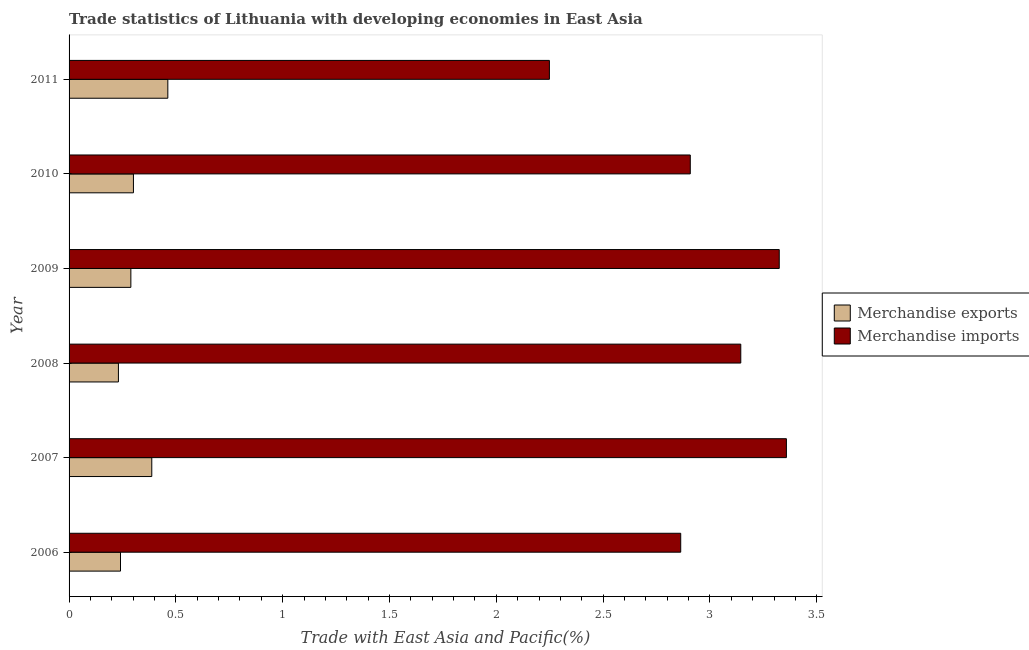Are the number of bars per tick equal to the number of legend labels?
Offer a very short reply. Yes. Are the number of bars on each tick of the Y-axis equal?
Make the answer very short. Yes. In how many cases, is the number of bars for a given year not equal to the number of legend labels?
Provide a short and direct response. 0. What is the merchandise imports in 2006?
Ensure brevity in your answer.  2.86. Across all years, what is the maximum merchandise exports?
Your response must be concise. 0.46. Across all years, what is the minimum merchandise exports?
Provide a succinct answer. 0.23. In which year was the merchandise exports maximum?
Ensure brevity in your answer.  2011. In which year was the merchandise imports minimum?
Provide a short and direct response. 2011. What is the total merchandise imports in the graph?
Your answer should be very brief. 17.85. What is the difference between the merchandise imports in 2007 and that in 2009?
Your answer should be very brief. 0.03. What is the difference between the merchandise exports in 2009 and the merchandise imports in 2007?
Make the answer very short. -3.07. What is the average merchandise exports per year?
Make the answer very short. 0.32. In the year 2008, what is the difference between the merchandise exports and merchandise imports?
Provide a short and direct response. -2.91. In how many years, is the merchandise imports greater than 1.4 %?
Your response must be concise. 6. What is the ratio of the merchandise exports in 2007 to that in 2010?
Keep it short and to the point. 1.28. What is the difference between the highest and the second highest merchandise exports?
Keep it short and to the point. 0.07. What is the difference between the highest and the lowest merchandise exports?
Keep it short and to the point. 0.23. In how many years, is the merchandise imports greater than the average merchandise imports taken over all years?
Keep it short and to the point. 3. What does the 2nd bar from the top in 2008 represents?
Make the answer very short. Merchandise exports. How many bars are there?
Your answer should be very brief. 12. Are all the bars in the graph horizontal?
Provide a succinct answer. Yes. How many years are there in the graph?
Offer a terse response. 6. Does the graph contain any zero values?
Offer a terse response. No. How many legend labels are there?
Your answer should be very brief. 2. What is the title of the graph?
Your response must be concise. Trade statistics of Lithuania with developing economies in East Asia. Does "IMF nonconcessional" appear as one of the legend labels in the graph?
Offer a very short reply. No. What is the label or title of the X-axis?
Provide a succinct answer. Trade with East Asia and Pacific(%). What is the label or title of the Y-axis?
Ensure brevity in your answer.  Year. What is the Trade with East Asia and Pacific(%) in Merchandise exports in 2006?
Your answer should be very brief. 0.24. What is the Trade with East Asia and Pacific(%) in Merchandise imports in 2006?
Your answer should be compact. 2.86. What is the Trade with East Asia and Pacific(%) in Merchandise exports in 2007?
Your response must be concise. 0.39. What is the Trade with East Asia and Pacific(%) of Merchandise imports in 2007?
Your answer should be very brief. 3.36. What is the Trade with East Asia and Pacific(%) in Merchandise exports in 2008?
Your answer should be compact. 0.23. What is the Trade with East Asia and Pacific(%) of Merchandise imports in 2008?
Your answer should be compact. 3.14. What is the Trade with East Asia and Pacific(%) in Merchandise exports in 2009?
Provide a succinct answer. 0.29. What is the Trade with East Asia and Pacific(%) of Merchandise imports in 2009?
Your answer should be compact. 3.32. What is the Trade with East Asia and Pacific(%) of Merchandise exports in 2010?
Make the answer very short. 0.3. What is the Trade with East Asia and Pacific(%) in Merchandise imports in 2010?
Offer a very short reply. 2.91. What is the Trade with East Asia and Pacific(%) in Merchandise exports in 2011?
Make the answer very short. 0.46. What is the Trade with East Asia and Pacific(%) in Merchandise imports in 2011?
Make the answer very short. 2.25. Across all years, what is the maximum Trade with East Asia and Pacific(%) in Merchandise exports?
Ensure brevity in your answer.  0.46. Across all years, what is the maximum Trade with East Asia and Pacific(%) of Merchandise imports?
Provide a short and direct response. 3.36. Across all years, what is the minimum Trade with East Asia and Pacific(%) of Merchandise exports?
Offer a very short reply. 0.23. Across all years, what is the minimum Trade with East Asia and Pacific(%) in Merchandise imports?
Offer a terse response. 2.25. What is the total Trade with East Asia and Pacific(%) of Merchandise exports in the graph?
Your answer should be very brief. 1.91. What is the total Trade with East Asia and Pacific(%) in Merchandise imports in the graph?
Your response must be concise. 17.85. What is the difference between the Trade with East Asia and Pacific(%) of Merchandise exports in 2006 and that in 2007?
Your response must be concise. -0.15. What is the difference between the Trade with East Asia and Pacific(%) of Merchandise imports in 2006 and that in 2007?
Offer a terse response. -0.49. What is the difference between the Trade with East Asia and Pacific(%) of Merchandise exports in 2006 and that in 2008?
Offer a terse response. 0.01. What is the difference between the Trade with East Asia and Pacific(%) of Merchandise imports in 2006 and that in 2008?
Your response must be concise. -0.28. What is the difference between the Trade with East Asia and Pacific(%) in Merchandise exports in 2006 and that in 2009?
Your answer should be very brief. -0.05. What is the difference between the Trade with East Asia and Pacific(%) in Merchandise imports in 2006 and that in 2009?
Provide a short and direct response. -0.46. What is the difference between the Trade with East Asia and Pacific(%) of Merchandise exports in 2006 and that in 2010?
Your response must be concise. -0.06. What is the difference between the Trade with East Asia and Pacific(%) in Merchandise imports in 2006 and that in 2010?
Make the answer very short. -0.04. What is the difference between the Trade with East Asia and Pacific(%) in Merchandise exports in 2006 and that in 2011?
Offer a very short reply. -0.22. What is the difference between the Trade with East Asia and Pacific(%) in Merchandise imports in 2006 and that in 2011?
Your answer should be very brief. 0.61. What is the difference between the Trade with East Asia and Pacific(%) in Merchandise exports in 2007 and that in 2008?
Keep it short and to the point. 0.16. What is the difference between the Trade with East Asia and Pacific(%) of Merchandise imports in 2007 and that in 2008?
Your response must be concise. 0.21. What is the difference between the Trade with East Asia and Pacific(%) in Merchandise exports in 2007 and that in 2009?
Ensure brevity in your answer.  0.1. What is the difference between the Trade with East Asia and Pacific(%) of Merchandise imports in 2007 and that in 2009?
Keep it short and to the point. 0.03. What is the difference between the Trade with East Asia and Pacific(%) in Merchandise exports in 2007 and that in 2010?
Make the answer very short. 0.09. What is the difference between the Trade with East Asia and Pacific(%) of Merchandise imports in 2007 and that in 2010?
Offer a very short reply. 0.45. What is the difference between the Trade with East Asia and Pacific(%) of Merchandise exports in 2007 and that in 2011?
Give a very brief answer. -0.08. What is the difference between the Trade with East Asia and Pacific(%) in Merchandise imports in 2007 and that in 2011?
Your answer should be very brief. 1.11. What is the difference between the Trade with East Asia and Pacific(%) in Merchandise exports in 2008 and that in 2009?
Make the answer very short. -0.06. What is the difference between the Trade with East Asia and Pacific(%) in Merchandise imports in 2008 and that in 2009?
Offer a terse response. -0.18. What is the difference between the Trade with East Asia and Pacific(%) in Merchandise exports in 2008 and that in 2010?
Your response must be concise. -0.07. What is the difference between the Trade with East Asia and Pacific(%) in Merchandise imports in 2008 and that in 2010?
Offer a terse response. 0.24. What is the difference between the Trade with East Asia and Pacific(%) in Merchandise exports in 2008 and that in 2011?
Keep it short and to the point. -0.23. What is the difference between the Trade with East Asia and Pacific(%) of Merchandise imports in 2008 and that in 2011?
Make the answer very short. 0.9. What is the difference between the Trade with East Asia and Pacific(%) in Merchandise exports in 2009 and that in 2010?
Offer a terse response. -0.01. What is the difference between the Trade with East Asia and Pacific(%) in Merchandise imports in 2009 and that in 2010?
Your response must be concise. 0.42. What is the difference between the Trade with East Asia and Pacific(%) in Merchandise exports in 2009 and that in 2011?
Keep it short and to the point. -0.17. What is the difference between the Trade with East Asia and Pacific(%) of Merchandise imports in 2009 and that in 2011?
Your answer should be compact. 1.08. What is the difference between the Trade with East Asia and Pacific(%) in Merchandise exports in 2010 and that in 2011?
Make the answer very short. -0.16. What is the difference between the Trade with East Asia and Pacific(%) in Merchandise imports in 2010 and that in 2011?
Your answer should be very brief. 0.66. What is the difference between the Trade with East Asia and Pacific(%) of Merchandise exports in 2006 and the Trade with East Asia and Pacific(%) of Merchandise imports in 2007?
Give a very brief answer. -3.12. What is the difference between the Trade with East Asia and Pacific(%) in Merchandise exports in 2006 and the Trade with East Asia and Pacific(%) in Merchandise imports in 2008?
Make the answer very short. -2.9. What is the difference between the Trade with East Asia and Pacific(%) in Merchandise exports in 2006 and the Trade with East Asia and Pacific(%) in Merchandise imports in 2009?
Give a very brief answer. -3.08. What is the difference between the Trade with East Asia and Pacific(%) of Merchandise exports in 2006 and the Trade with East Asia and Pacific(%) of Merchandise imports in 2010?
Your answer should be very brief. -2.67. What is the difference between the Trade with East Asia and Pacific(%) in Merchandise exports in 2006 and the Trade with East Asia and Pacific(%) in Merchandise imports in 2011?
Your response must be concise. -2.01. What is the difference between the Trade with East Asia and Pacific(%) of Merchandise exports in 2007 and the Trade with East Asia and Pacific(%) of Merchandise imports in 2008?
Keep it short and to the point. -2.76. What is the difference between the Trade with East Asia and Pacific(%) of Merchandise exports in 2007 and the Trade with East Asia and Pacific(%) of Merchandise imports in 2009?
Offer a terse response. -2.94. What is the difference between the Trade with East Asia and Pacific(%) in Merchandise exports in 2007 and the Trade with East Asia and Pacific(%) in Merchandise imports in 2010?
Your answer should be very brief. -2.52. What is the difference between the Trade with East Asia and Pacific(%) of Merchandise exports in 2007 and the Trade with East Asia and Pacific(%) of Merchandise imports in 2011?
Make the answer very short. -1.86. What is the difference between the Trade with East Asia and Pacific(%) in Merchandise exports in 2008 and the Trade with East Asia and Pacific(%) in Merchandise imports in 2009?
Keep it short and to the point. -3.09. What is the difference between the Trade with East Asia and Pacific(%) in Merchandise exports in 2008 and the Trade with East Asia and Pacific(%) in Merchandise imports in 2010?
Give a very brief answer. -2.68. What is the difference between the Trade with East Asia and Pacific(%) in Merchandise exports in 2008 and the Trade with East Asia and Pacific(%) in Merchandise imports in 2011?
Keep it short and to the point. -2.02. What is the difference between the Trade with East Asia and Pacific(%) in Merchandise exports in 2009 and the Trade with East Asia and Pacific(%) in Merchandise imports in 2010?
Offer a very short reply. -2.62. What is the difference between the Trade with East Asia and Pacific(%) of Merchandise exports in 2009 and the Trade with East Asia and Pacific(%) of Merchandise imports in 2011?
Your response must be concise. -1.96. What is the difference between the Trade with East Asia and Pacific(%) in Merchandise exports in 2010 and the Trade with East Asia and Pacific(%) in Merchandise imports in 2011?
Keep it short and to the point. -1.95. What is the average Trade with East Asia and Pacific(%) in Merchandise exports per year?
Provide a short and direct response. 0.32. What is the average Trade with East Asia and Pacific(%) in Merchandise imports per year?
Make the answer very short. 2.97. In the year 2006, what is the difference between the Trade with East Asia and Pacific(%) of Merchandise exports and Trade with East Asia and Pacific(%) of Merchandise imports?
Offer a terse response. -2.62. In the year 2007, what is the difference between the Trade with East Asia and Pacific(%) in Merchandise exports and Trade with East Asia and Pacific(%) in Merchandise imports?
Your answer should be compact. -2.97. In the year 2008, what is the difference between the Trade with East Asia and Pacific(%) of Merchandise exports and Trade with East Asia and Pacific(%) of Merchandise imports?
Offer a very short reply. -2.91. In the year 2009, what is the difference between the Trade with East Asia and Pacific(%) in Merchandise exports and Trade with East Asia and Pacific(%) in Merchandise imports?
Provide a short and direct response. -3.04. In the year 2010, what is the difference between the Trade with East Asia and Pacific(%) in Merchandise exports and Trade with East Asia and Pacific(%) in Merchandise imports?
Provide a succinct answer. -2.61. In the year 2011, what is the difference between the Trade with East Asia and Pacific(%) of Merchandise exports and Trade with East Asia and Pacific(%) of Merchandise imports?
Your answer should be compact. -1.79. What is the ratio of the Trade with East Asia and Pacific(%) of Merchandise exports in 2006 to that in 2007?
Your answer should be very brief. 0.62. What is the ratio of the Trade with East Asia and Pacific(%) in Merchandise imports in 2006 to that in 2007?
Keep it short and to the point. 0.85. What is the ratio of the Trade with East Asia and Pacific(%) of Merchandise exports in 2006 to that in 2008?
Provide a short and direct response. 1.04. What is the ratio of the Trade with East Asia and Pacific(%) of Merchandise imports in 2006 to that in 2008?
Your answer should be compact. 0.91. What is the ratio of the Trade with East Asia and Pacific(%) in Merchandise exports in 2006 to that in 2009?
Provide a short and direct response. 0.83. What is the ratio of the Trade with East Asia and Pacific(%) in Merchandise imports in 2006 to that in 2009?
Provide a succinct answer. 0.86. What is the ratio of the Trade with East Asia and Pacific(%) of Merchandise exports in 2006 to that in 2010?
Keep it short and to the point. 0.8. What is the ratio of the Trade with East Asia and Pacific(%) of Merchandise imports in 2006 to that in 2010?
Give a very brief answer. 0.98. What is the ratio of the Trade with East Asia and Pacific(%) of Merchandise exports in 2006 to that in 2011?
Your answer should be very brief. 0.52. What is the ratio of the Trade with East Asia and Pacific(%) of Merchandise imports in 2006 to that in 2011?
Offer a terse response. 1.27. What is the ratio of the Trade with East Asia and Pacific(%) in Merchandise exports in 2007 to that in 2008?
Offer a very short reply. 1.68. What is the ratio of the Trade with East Asia and Pacific(%) of Merchandise imports in 2007 to that in 2008?
Offer a terse response. 1.07. What is the ratio of the Trade with East Asia and Pacific(%) of Merchandise exports in 2007 to that in 2009?
Keep it short and to the point. 1.34. What is the ratio of the Trade with East Asia and Pacific(%) in Merchandise exports in 2007 to that in 2010?
Give a very brief answer. 1.28. What is the ratio of the Trade with East Asia and Pacific(%) in Merchandise imports in 2007 to that in 2010?
Provide a short and direct response. 1.15. What is the ratio of the Trade with East Asia and Pacific(%) in Merchandise exports in 2007 to that in 2011?
Provide a succinct answer. 0.84. What is the ratio of the Trade with East Asia and Pacific(%) of Merchandise imports in 2007 to that in 2011?
Your response must be concise. 1.49. What is the ratio of the Trade with East Asia and Pacific(%) of Merchandise exports in 2008 to that in 2009?
Provide a succinct answer. 0.8. What is the ratio of the Trade with East Asia and Pacific(%) in Merchandise imports in 2008 to that in 2009?
Ensure brevity in your answer.  0.95. What is the ratio of the Trade with East Asia and Pacific(%) in Merchandise exports in 2008 to that in 2010?
Offer a very short reply. 0.77. What is the ratio of the Trade with East Asia and Pacific(%) in Merchandise imports in 2008 to that in 2010?
Offer a very short reply. 1.08. What is the ratio of the Trade with East Asia and Pacific(%) of Merchandise exports in 2008 to that in 2011?
Offer a very short reply. 0.5. What is the ratio of the Trade with East Asia and Pacific(%) of Merchandise imports in 2008 to that in 2011?
Your answer should be very brief. 1.4. What is the ratio of the Trade with East Asia and Pacific(%) of Merchandise imports in 2009 to that in 2010?
Offer a very short reply. 1.14. What is the ratio of the Trade with East Asia and Pacific(%) of Merchandise exports in 2009 to that in 2011?
Offer a terse response. 0.63. What is the ratio of the Trade with East Asia and Pacific(%) of Merchandise imports in 2009 to that in 2011?
Your response must be concise. 1.48. What is the ratio of the Trade with East Asia and Pacific(%) in Merchandise exports in 2010 to that in 2011?
Offer a very short reply. 0.65. What is the ratio of the Trade with East Asia and Pacific(%) of Merchandise imports in 2010 to that in 2011?
Offer a very short reply. 1.29. What is the difference between the highest and the second highest Trade with East Asia and Pacific(%) in Merchandise exports?
Keep it short and to the point. 0.08. What is the difference between the highest and the second highest Trade with East Asia and Pacific(%) of Merchandise imports?
Offer a very short reply. 0.03. What is the difference between the highest and the lowest Trade with East Asia and Pacific(%) of Merchandise exports?
Ensure brevity in your answer.  0.23. What is the difference between the highest and the lowest Trade with East Asia and Pacific(%) in Merchandise imports?
Your answer should be compact. 1.11. 